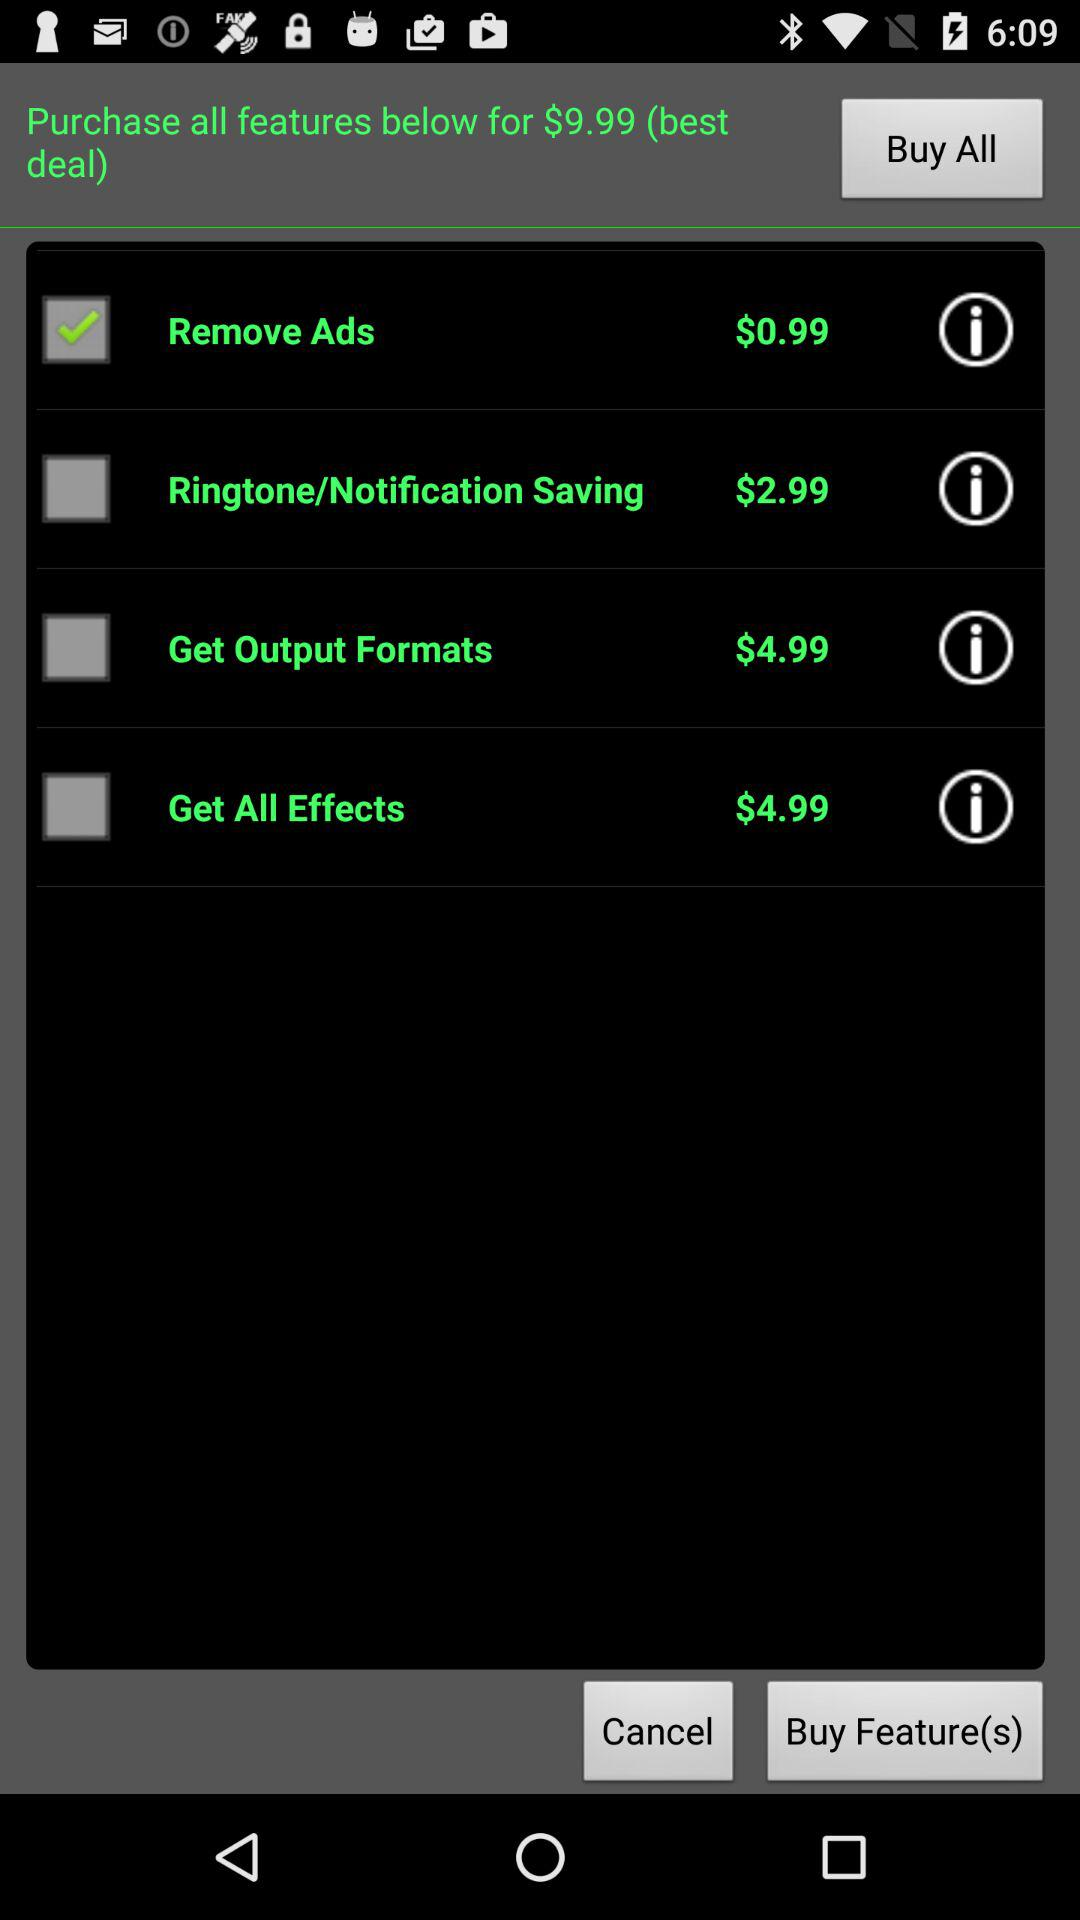What is the status of "Remove Ads"? The status is "on". 